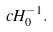Convert formula to latex. <formula><loc_0><loc_0><loc_500><loc_500>c H _ { 0 } ^ { - 1 } .</formula> 